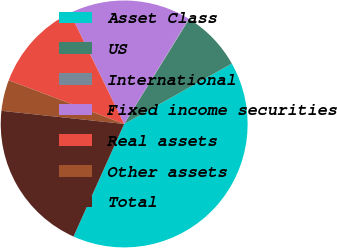<chart> <loc_0><loc_0><loc_500><loc_500><pie_chart><fcel>Asset Class<fcel>US<fcel>International<fcel>Fixed income securities<fcel>Real assets<fcel>Other assets<fcel>Total<nl><fcel>39.86%<fcel>8.03%<fcel>0.08%<fcel>15.99%<fcel>12.01%<fcel>4.06%<fcel>19.97%<nl></chart> 